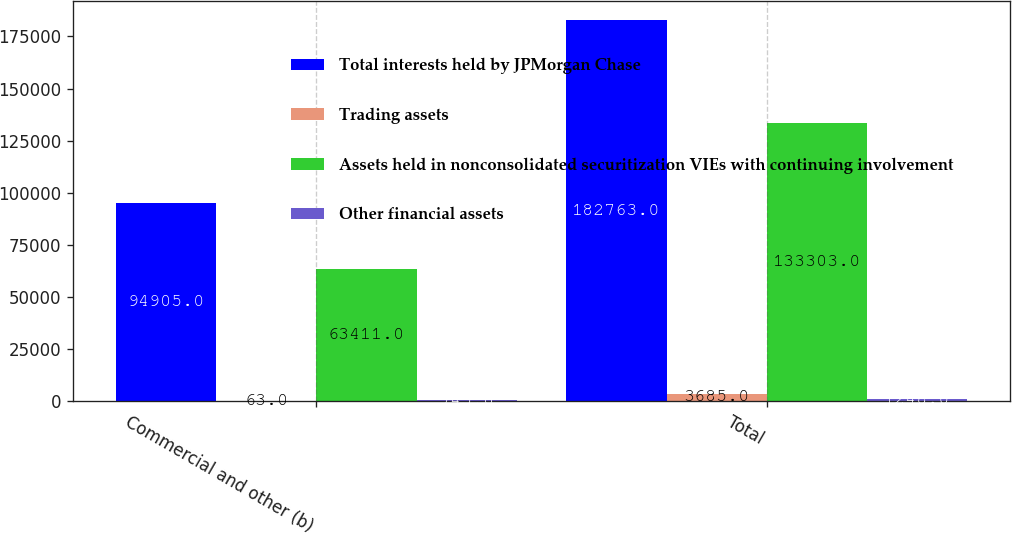Convert chart to OTSL. <chart><loc_0><loc_0><loc_500><loc_500><stacked_bar_chart><ecel><fcel>Commercial and other (b)<fcel>Total<nl><fcel>Total interests held by JPMorgan Chase<fcel>94905<fcel>182763<nl><fcel>Trading assets<fcel>63<fcel>3685<nl><fcel>Assets held in nonconsolidated securitization VIEs with continuing involvement<fcel>63411<fcel>133303<nl><fcel>Other financial assets<fcel>745<fcel>1248<nl></chart> 